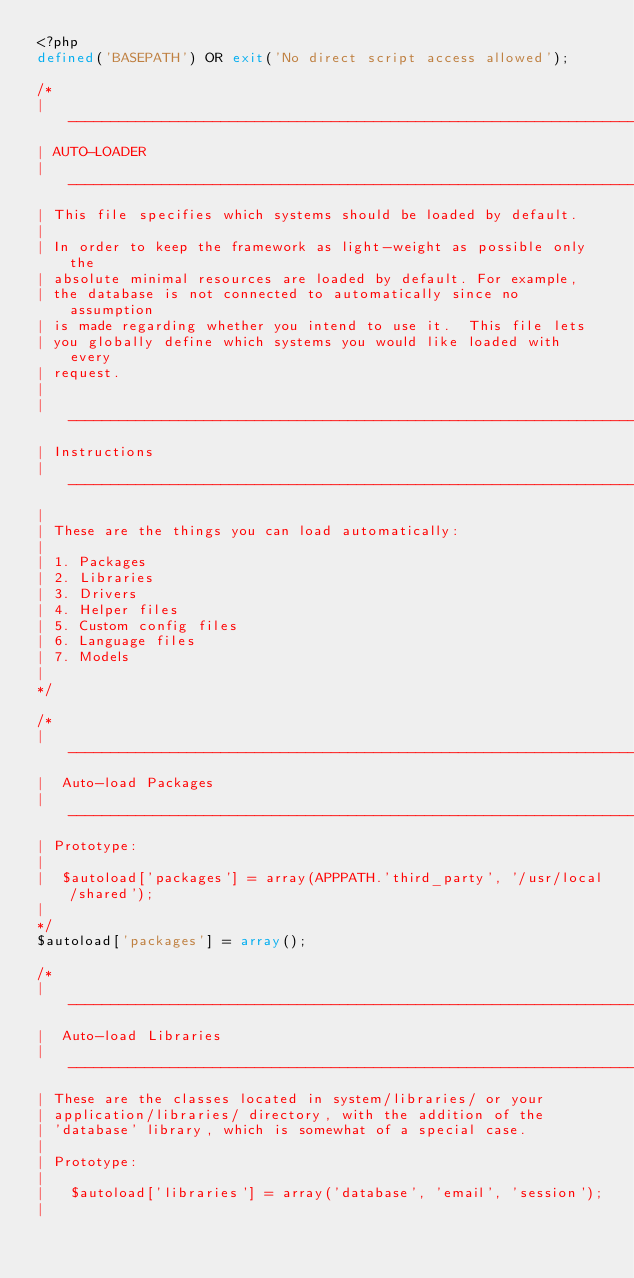Convert code to text. <code><loc_0><loc_0><loc_500><loc_500><_PHP_><?php
defined('BASEPATH') OR exit('No direct script access allowed');

/*
| -------------------------------------------------------------------
| AUTO-LOADER
| -------------------------------------------------------------------
| This file specifies which systems should be loaded by default.
|
| In order to keep the framework as light-weight as possible only the
| absolute minimal resources are loaded by default. For example,
| the database is not connected to automatically since no assumption
| is made regarding whether you intend to use it.  This file lets
| you globally define which systems you would like loaded with every
| request.
|
| -------------------------------------------------------------------
| Instructions
| -------------------------------------------------------------------
|
| These are the things you can load automatically:
|
| 1. Packages
| 2. Libraries
| 3. Drivers
| 4. Helper files
| 5. Custom config files
| 6. Language files
| 7. Models
|
*/

/*
| -------------------------------------------------------------------
|  Auto-load Packages
| -------------------------------------------------------------------
| Prototype:
|
|  $autoload['packages'] = array(APPPATH.'third_party', '/usr/local/shared');
|
*/
$autoload['packages'] = array();

/*
| -------------------------------------------------------------------
|  Auto-load Libraries
| -------------------------------------------------------------------
| These are the classes located in system/libraries/ or your
| application/libraries/ directory, with the addition of the
| 'database' library, which is somewhat of a special case.
|
| Prototype:
|
|	$autoload['libraries'] = array('database', 'email', 'session');
|</code> 